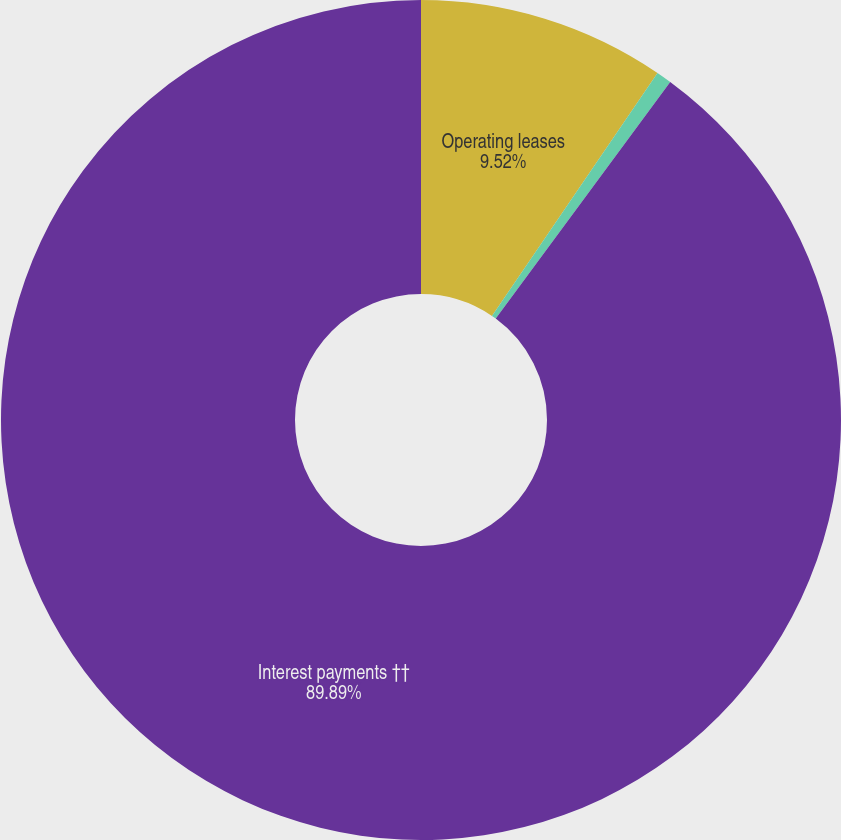Convert chart. <chart><loc_0><loc_0><loc_500><loc_500><pie_chart><fcel>Operating leases<fcel>Minimum royalty obligations<fcel>Interest payments ††<nl><fcel>9.52%<fcel>0.59%<fcel>89.89%<nl></chart> 